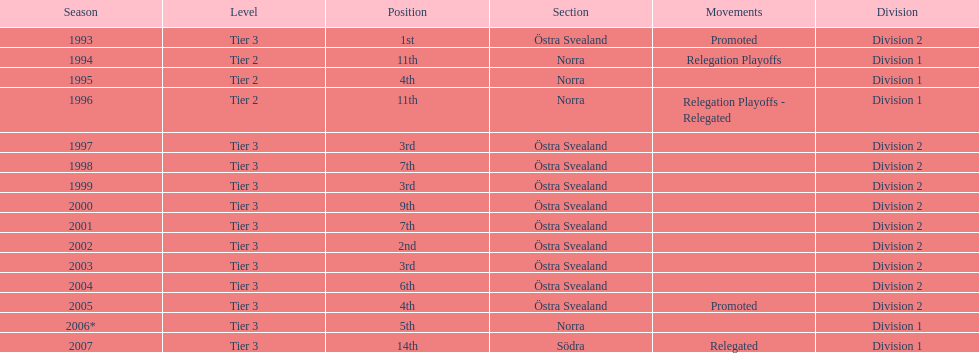How many times did they finish above 5th place in division 2 tier 3? 6. 